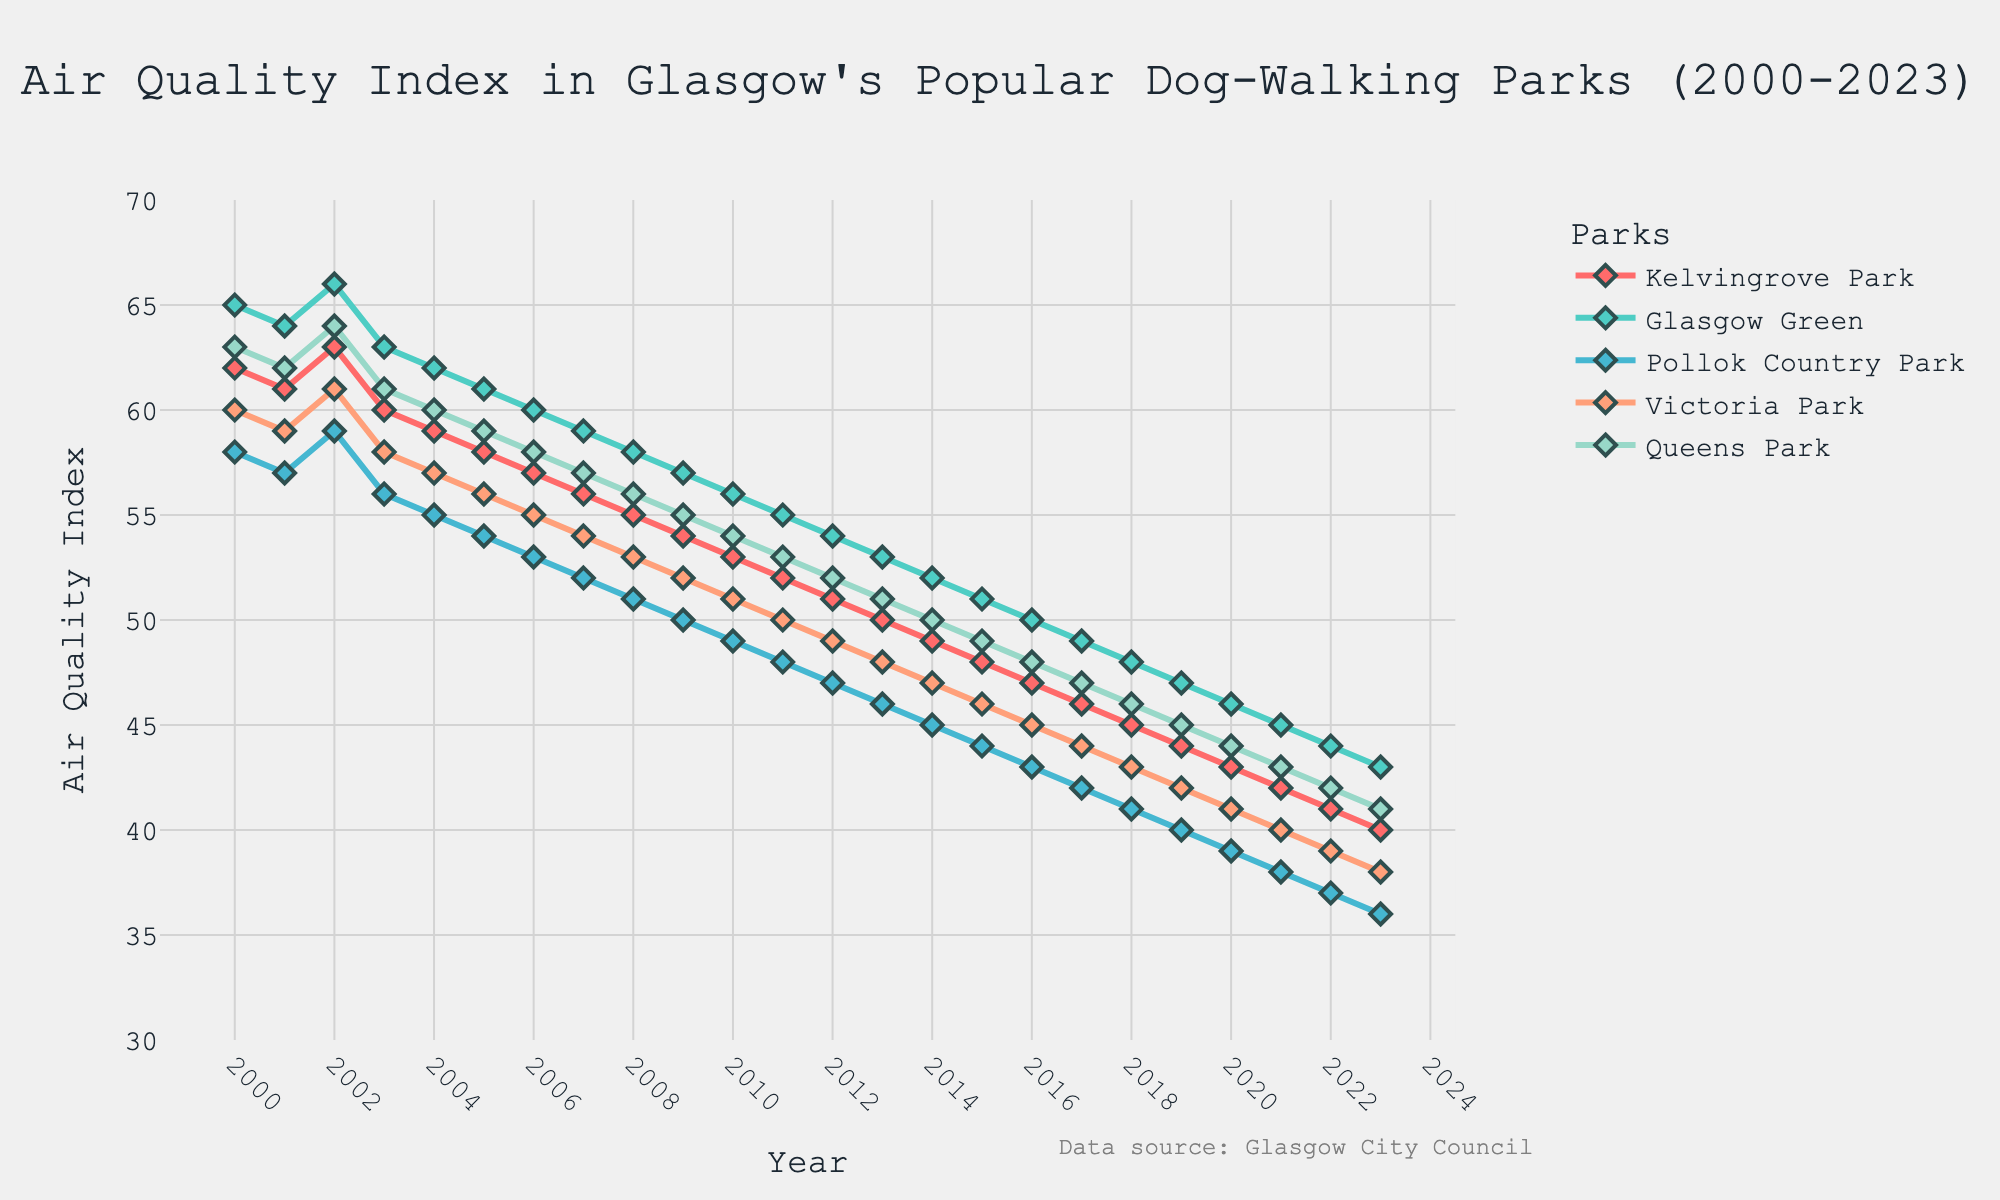What is the trend in the air quality index for Kelvingrove Park from 2000 to 2023? To identify the trend, look at the values for Kelvingrove Park from 2000 to 2023. The air quality index decreases from 62 in 2000 to 40 in 2023, indicating an overall improvement in air quality.
Answer: Decreasing trend Which park had the highest air quality index in the year 2003? Check the values for each park in the year 2003. Kelvingrove Park has an index of 60, Glasgow Green 63, Pollok Country Park 56, Victoria Park 58, and Queens Park 61. Glasgow Green has the highest value, 63.
Answer: Glasgow Green What is the average air quality index for Queens Park over the years 2000 to 2023? Sum the air quality index values for Queens Park from 2000 to 2023 and divide by the number of years (24). The sum is 63 + 62 + 64 + 61 + 60 + 59 + 58 + 57 + 56 + 55 + 54 + 53 + 52 + 51 + 50 + 49 + 48 + 47 + 46 + 45 + 44 + 43 + 42 + 41 = 1304, so the average is 1304 / 24 = 52.5.
Answer: 52.5 Between which years did Victoria Park see the most significant improvement in air quality index? Compare the differences in air quality index values between consecutive years for Victoria Park. The most significant drop is from 2003 to 2004, where the index falls from 58 to 57.
Answer: 2003-2004 How does the air quality index of Pollok Country Park in 2023 compare to its value in 2000? Locate the values for Pollok Country Park in 2000 and 2023. The index decreases from 58 in 2000 to 36 in 2023, showing an improvement.
Answer: Improved Which park consistently showed the lowest air quality index through the given period? By comparing the air quality indices over all years, notice that Pollok Country Park has the lowest values each year compared to the other parks.
Answer: Pollok Country Park In which year did all parks have their highest collective air quality indices? Check which year has the highest sum of air quality indices across all parks. 2002 has the highest sum of (63 + 66 + 59 + 61 + 64) = 313.
Answer: 2002 What was the rate of improvement in air quality index for Glasgow Green from 2018 to 2023? Calculate the difference in the air quality index of Glasgow Green between 2018 and 2023 and divide by the number of years. The improvement is from 48 in 2018 to 43 in 2023. The rate is (48 - 43) / (2023 - 2018) = 5 / 5 = 1 index point per year.
Answer: 1 index point per year 